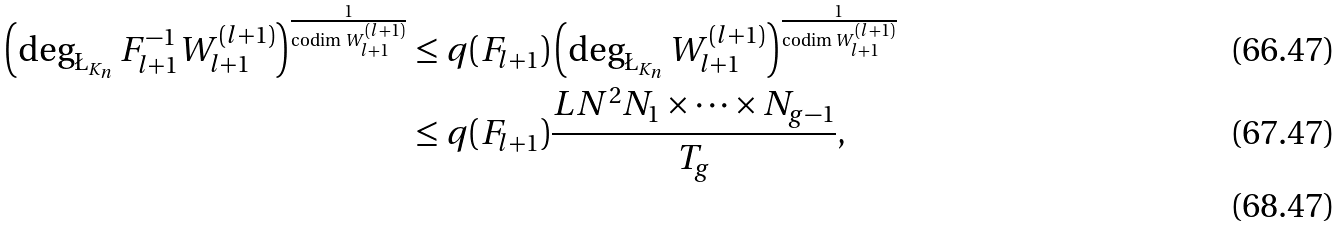<formula> <loc_0><loc_0><loc_500><loc_500>\left ( \deg _ { \L _ { K _ { n } } } F _ { l + 1 } ^ { - 1 } W _ { l + 1 } ^ { ( l + 1 ) } \right ) ^ { \frac { 1 } { \text {codim } W _ { l + 1 } ^ { ( l + 1 ) } } } & \leq q ( F _ { l + 1 } ) \left ( \deg _ { \L _ { K _ { n } } } W _ { l + 1 } ^ { ( l + 1 ) } \right ) ^ { \frac { 1 } { \text {codim } W _ { l + 1 } ^ { ( l + 1 ) } } } \\ & \leq q ( F _ { l + 1 } ) \frac { L N ^ { 2 } N _ { 1 } \times \cdots \times N _ { g - 1 } } { T _ { g } } , \\</formula> 